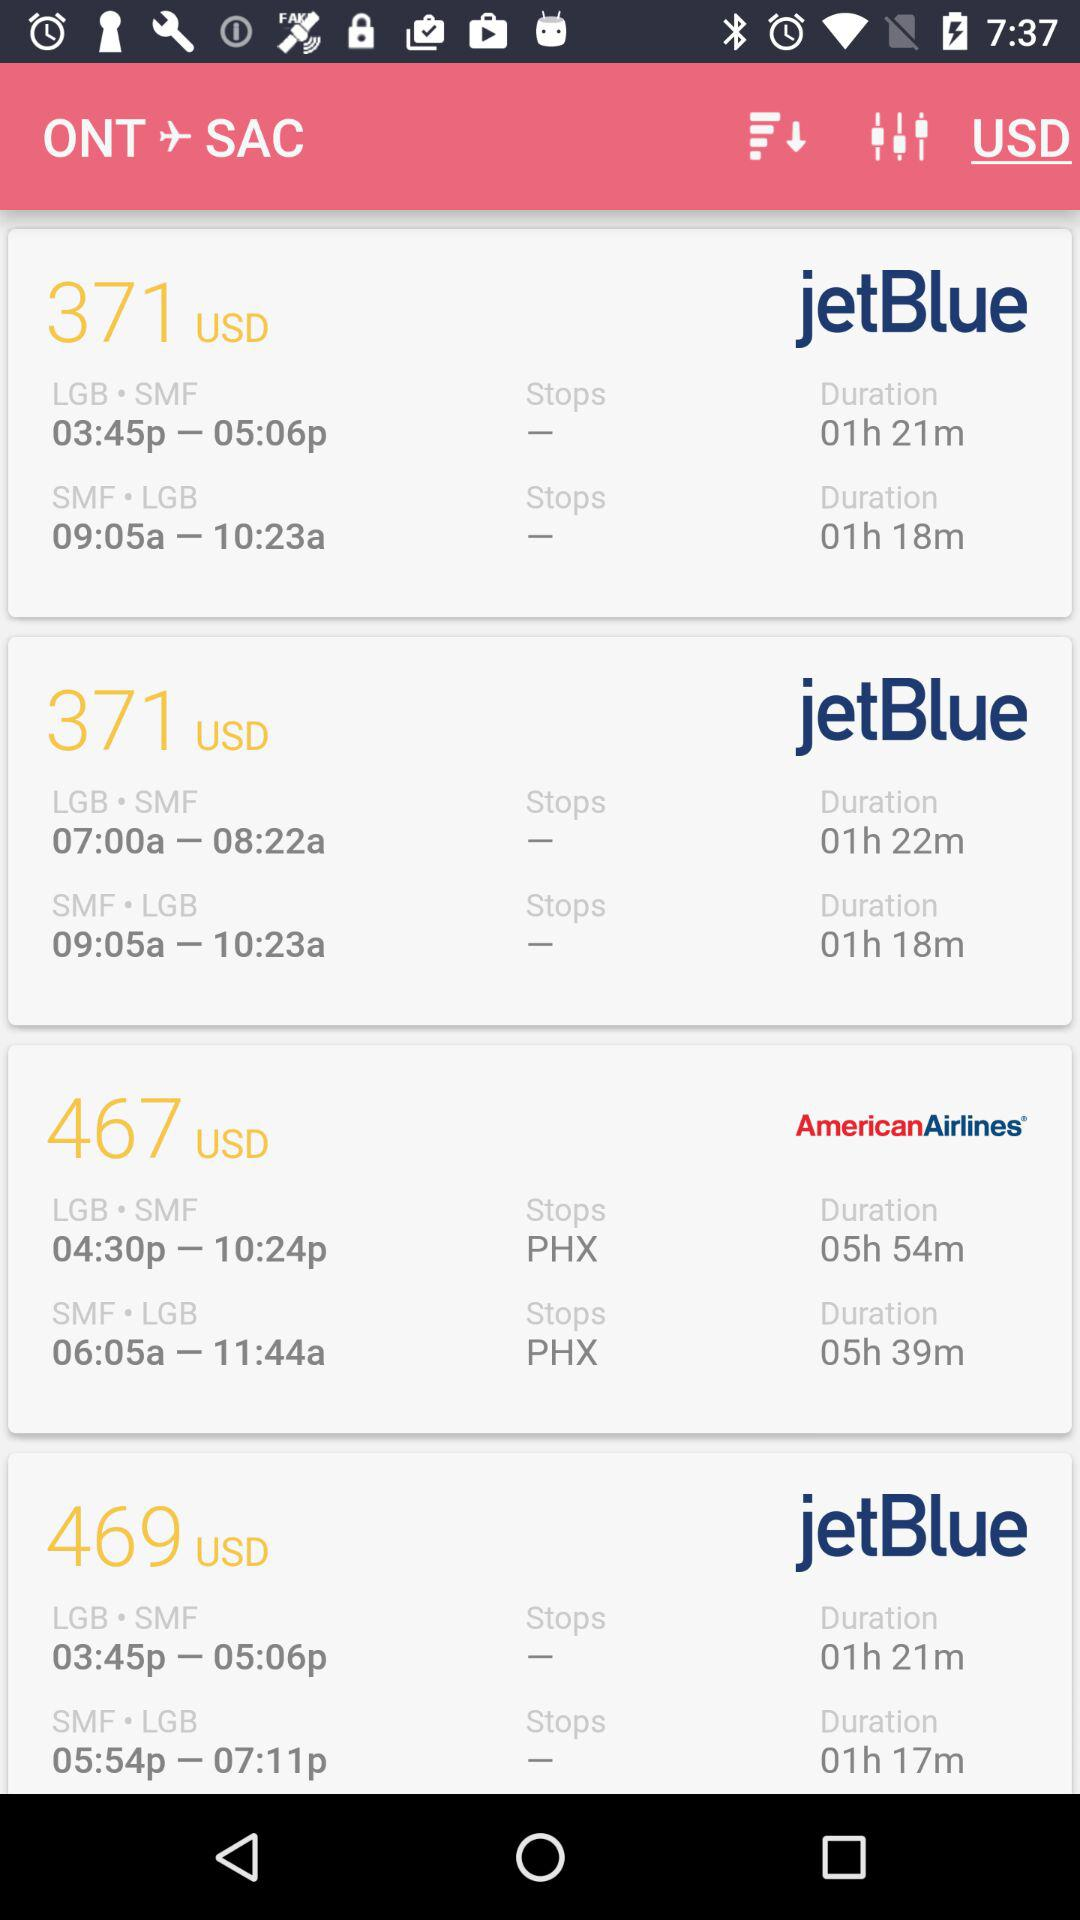Which airline has the most flights?
Answer the question using a single word or phrase. JetBlue 